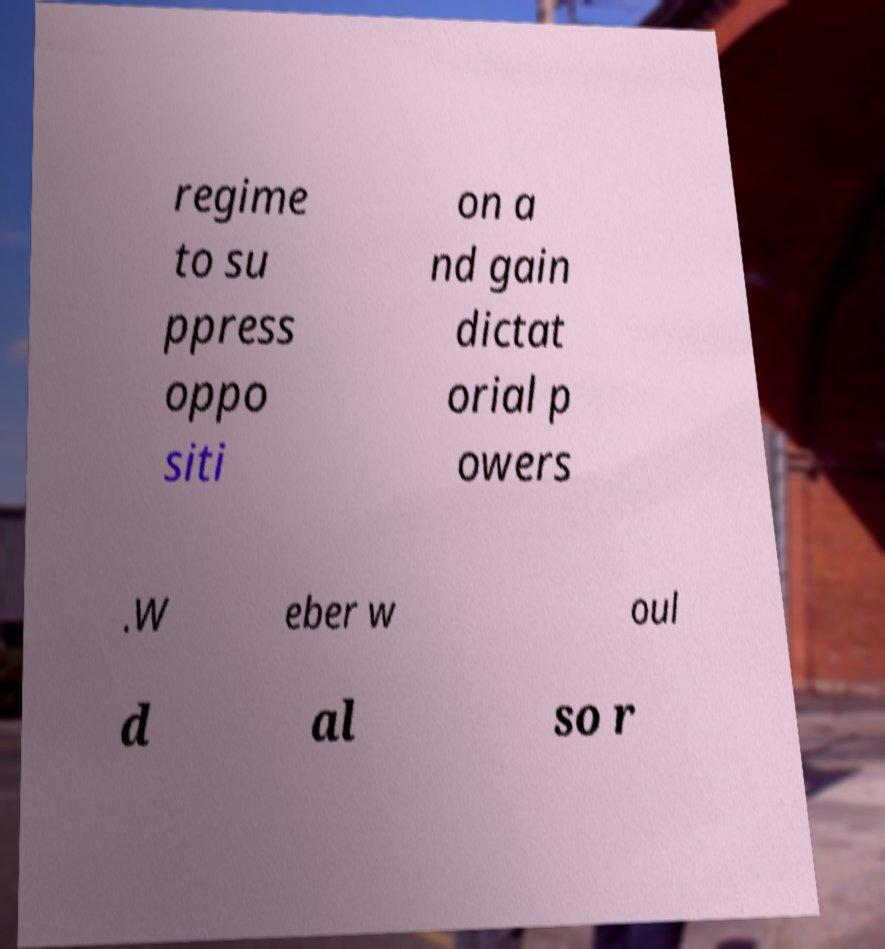Please read and relay the text visible in this image. What does it say? regime to su ppress oppo siti on a nd gain dictat orial p owers .W eber w oul d al so r 